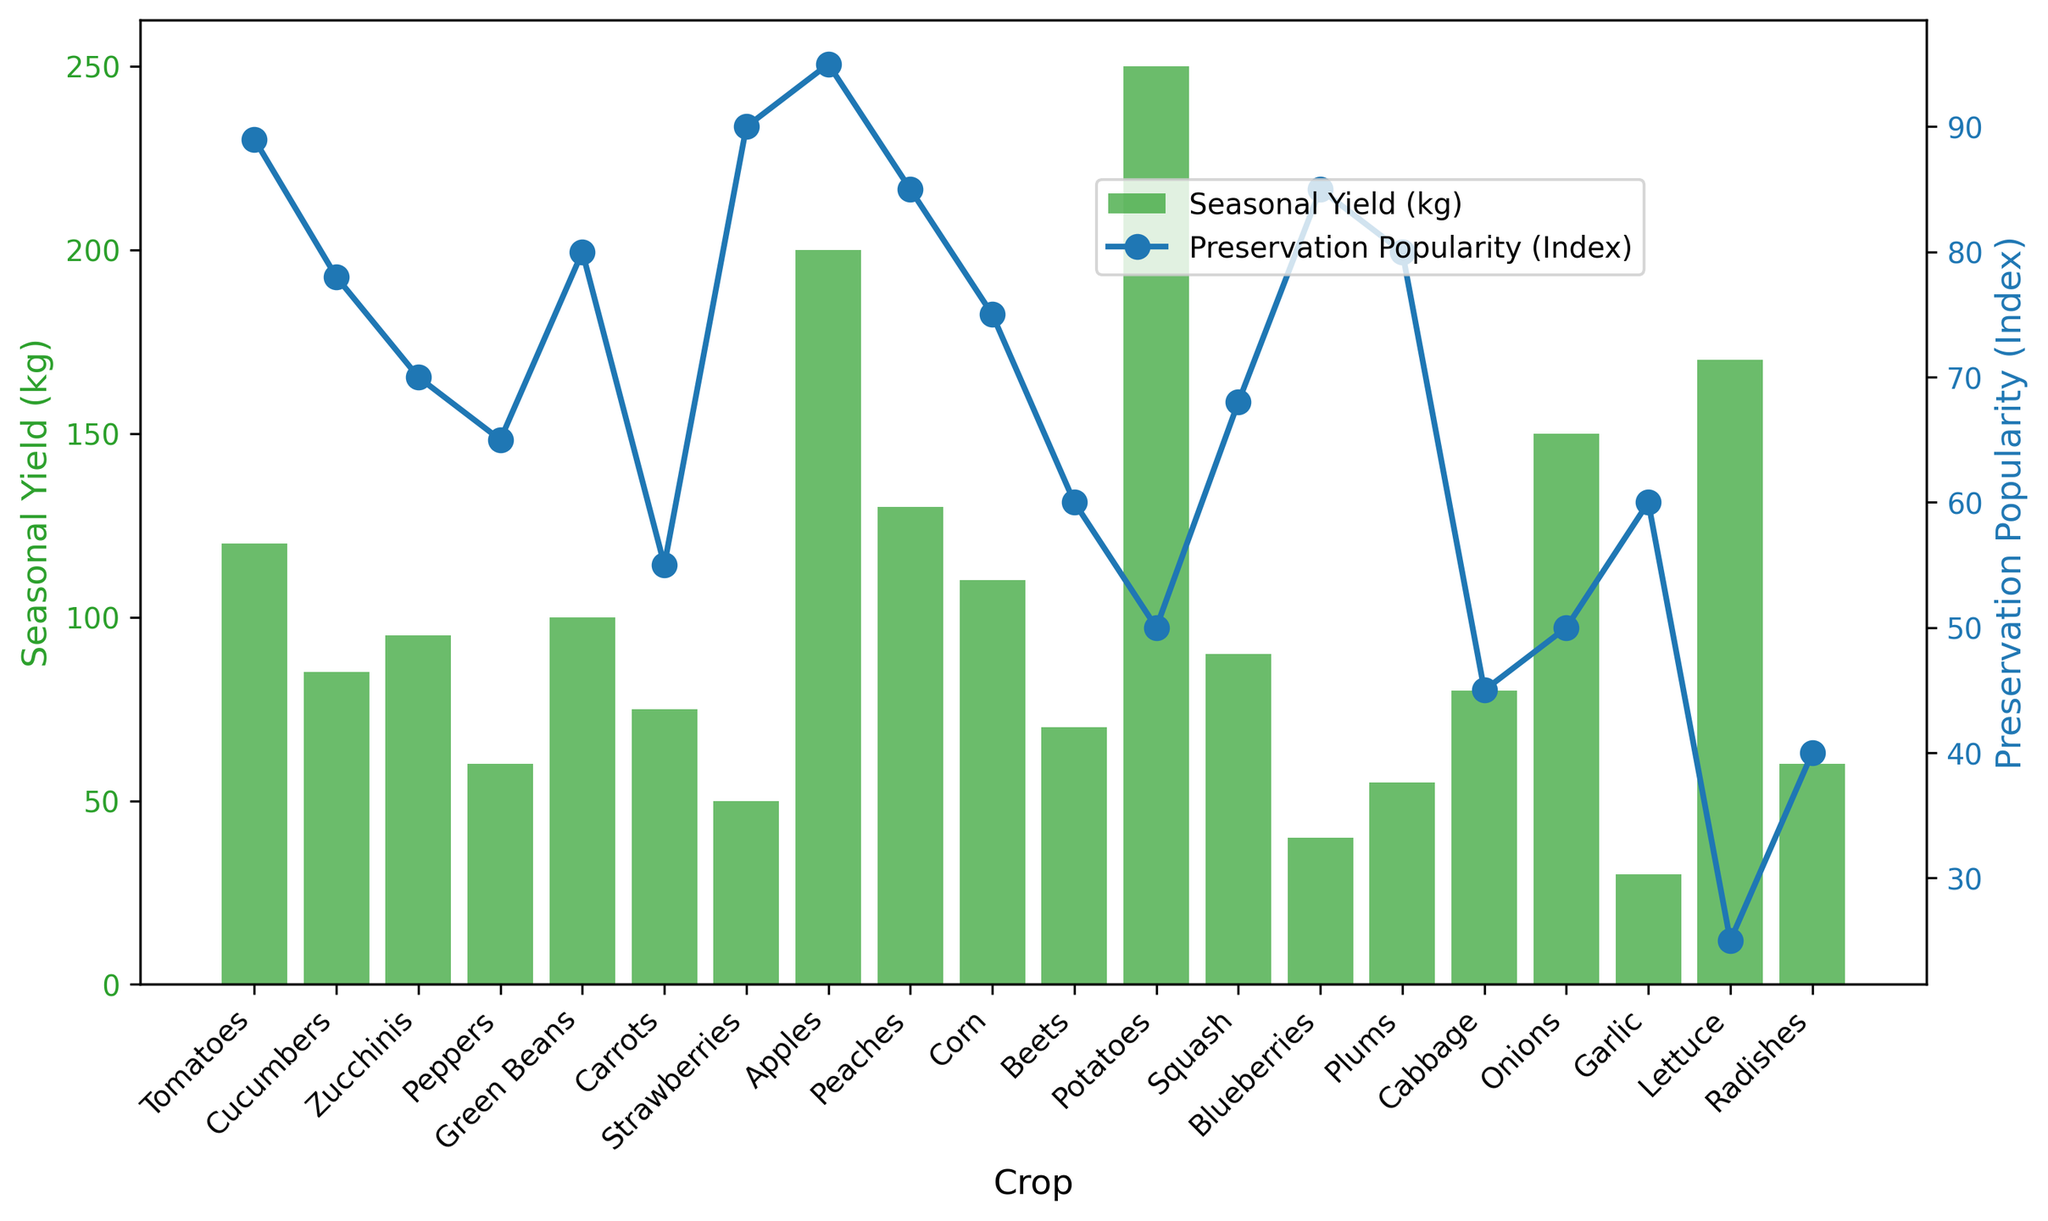What crop has the highest seasonal yield? By examining the bars on the primary y-axis, we can see that the tallest bar represents Potatoes, indicating the highest seasonal yield.
Answer: Potatoes Which crop has the lowest preservation popularity? Observing the secondary y-axis with blue markers, the lowest point belongs to Lettuce, showing it has the lowest preservation popularity.
Answer: Lettuce What is the difference in seasonal yield between Tomatoes and Peppers? The seasonal yield for Tomatoes is 120 kg, and for Peppers, it is 60 kg. Subtracting the latter from the former gives 120 kg - 60 kg = 60 kg.
Answer: 60 kg How do the seasonal yields of Corn and Green Beans compare? The bars for Corn and Green Beans are close in height. Specifically, Corn has a yield of 110 kg, and Green Beans have a yield of 100 kg, making Corn slightly higher.
Answer: Corn What is the combined preservation popularity index of Strawberries and Apples? Strawberries have an index of 90, and Apples have an index of 95. Adding these gives 90 + 95 = 185.
Answer: 185 Which crop has the greatest difference between seasonal yield and preservation popularity index, and what is that difference? By calculating the difference for each crop, the greatest difference is for Potatoes: 250 (yield) - 50 (popularity) = 200.
Answer: Potatoes, 200 What is the average preservation popularity index for Peppers, Beets, and Garlic? Summing their indices: 65 (Peppers) + 60 (Beets) + 60 (Garlic) = 185. Dividing by 3 gives 185 / 3 ≈ 61.67.
Answer: 61.67 Which crop has both a high seasonal yield and high preservation popularity index? Looking at both axes, Apples have the highest combination with a yield of 200 kg and a popularity index of 95.
Answer: Apples What are the preservation popularity indices of crops with seasonal yields above 100 kg? The crops with yields above 100 kg are Tomatoes (89), Apples (95), Peaches (85), Corn (75), Potatoes (50), and Onions (50). These crops have popularity indices of 89, 95, 85, 75, 50, and 50 respectively.
Answer: 89, 95, 85, 75, 50, 50 For crops below a 50 preservation popularity index, what is their average seasonal yield? Only Cabbage (80 kg) and Lettuce (170 kg) have < 50 popularity indices. Their average yield is (80 + 170) / 2 = 250 / 2 = 125.
Answer: 125 